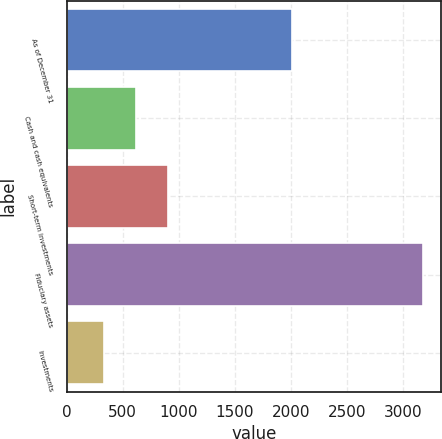Convert chart. <chart><loc_0><loc_0><loc_500><loc_500><bar_chart><fcel>As of December 31<fcel>Cash and cash equivalents<fcel>Short-term investments<fcel>Fiduciary assets<fcel>Investments<nl><fcel>2008<fcel>616.6<fcel>901.2<fcel>3178<fcel>332<nl></chart> 